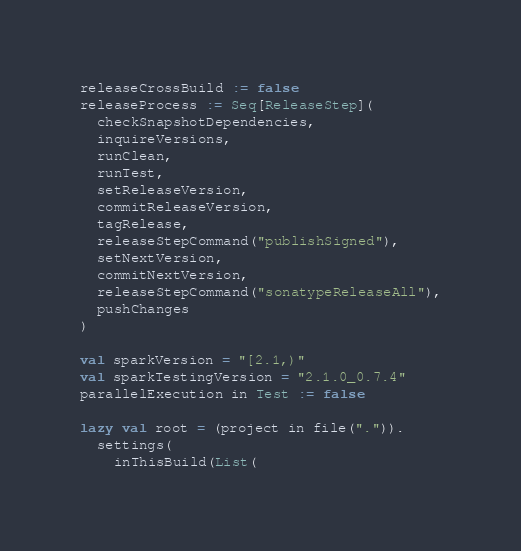<code> <loc_0><loc_0><loc_500><loc_500><_Scala_>releaseCrossBuild := false
releaseProcess := Seq[ReleaseStep](
  checkSnapshotDependencies,
  inquireVersions,
  runClean,
  runTest,
  setReleaseVersion,
  commitReleaseVersion,
  tagRelease,
  releaseStepCommand("publishSigned"),
  setNextVersion,
  commitNextVersion,
  releaseStepCommand("sonatypeReleaseAll"),
  pushChanges
)

val sparkVersion = "[2.1,)"
val sparkTestingVersion = "2.1.0_0.7.4"
parallelExecution in Test := false

lazy val root = (project in file(".")).
  settings(
    inThisBuild(List(</code> 